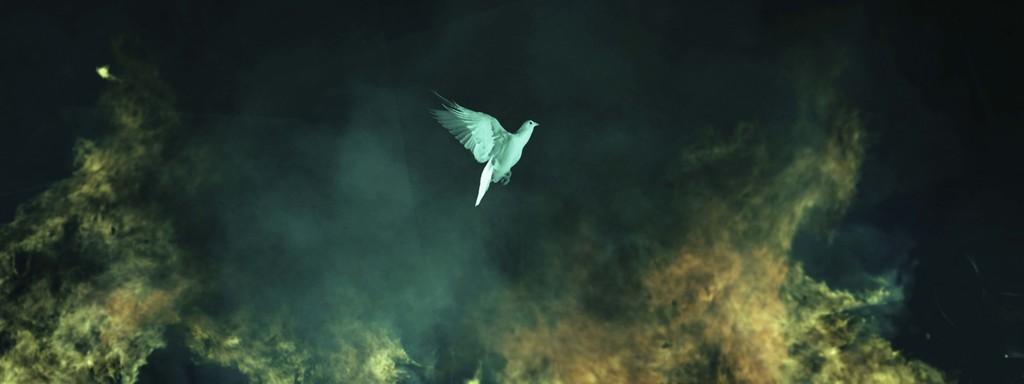In one or two sentences, can you explain what this image depicts? In this image we can see a bird flying. Behind the bird we can see the fire and the smoke. 